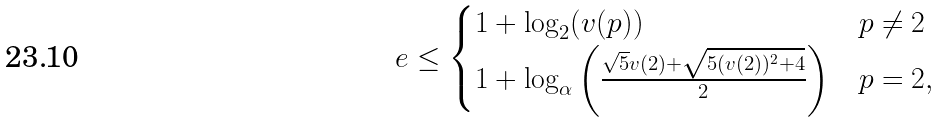Convert formula to latex. <formula><loc_0><loc_0><loc_500><loc_500>e \leq \begin{cases} 1 + \log _ { 2 } ( v ( p ) ) & p \neq 2 \\ 1 + \log _ { \alpha } \left ( \frac { \sqrt { 5 } v ( 2 ) + \sqrt { 5 ( v ( 2 ) ) ^ { 2 } + 4 } } { 2 } \right ) & p = 2 , \end{cases}</formula> 